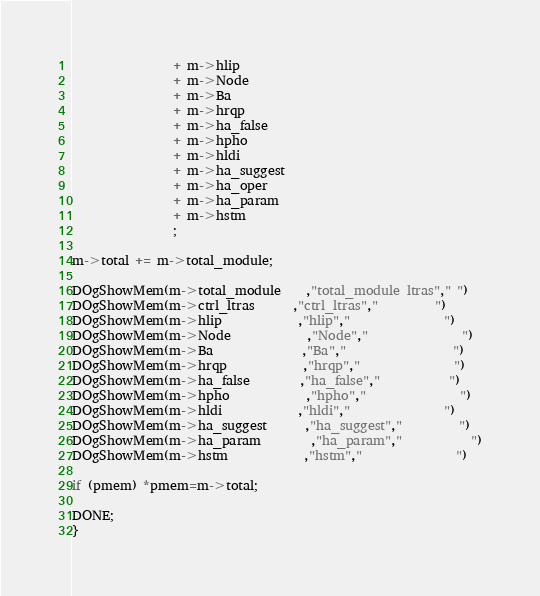<code> <loc_0><loc_0><loc_500><loc_500><_C_>                + m->hlip
                + m->Node
                + m->Ba
                + m->hrqp
                + m->ha_false
                + m->hpho
                + m->hldi
                + m->ha_suggest
                + m->ha_oper
                + m->ha_param
                + m->hstm
                ;

m->total += m->total_module;

DOgShowMem(m->total_module    ,"total_module ltras"," ")
DOgShowMem(m->ctrl_ltras      ,"ctrl_ltras","         ")
DOgShowMem(m->hlip            ,"hlip","               ")
DOgShowMem(m->Node            ,"Node","               ")
DOgShowMem(m->Ba              ,"Ba","                 ")
DOgShowMem(m->hrqp            ,"hrqp","               ")
DOgShowMem(m->ha_false        ,"ha_false","           ")
DOgShowMem(m->hpho            ,"hpho","               ")
DOgShowMem(m->hldi            ,"hldi","               ")
DOgShowMem(m->ha_suggest      ,"ha_suggest","         ")
DOgShowMem(m->ha_param        ,"ha_param","           ")
DOgShowMem(m->hstm            ,"hstm","               ")

if (pmem) *pmem=m->total;

DONE;
}




</code> 